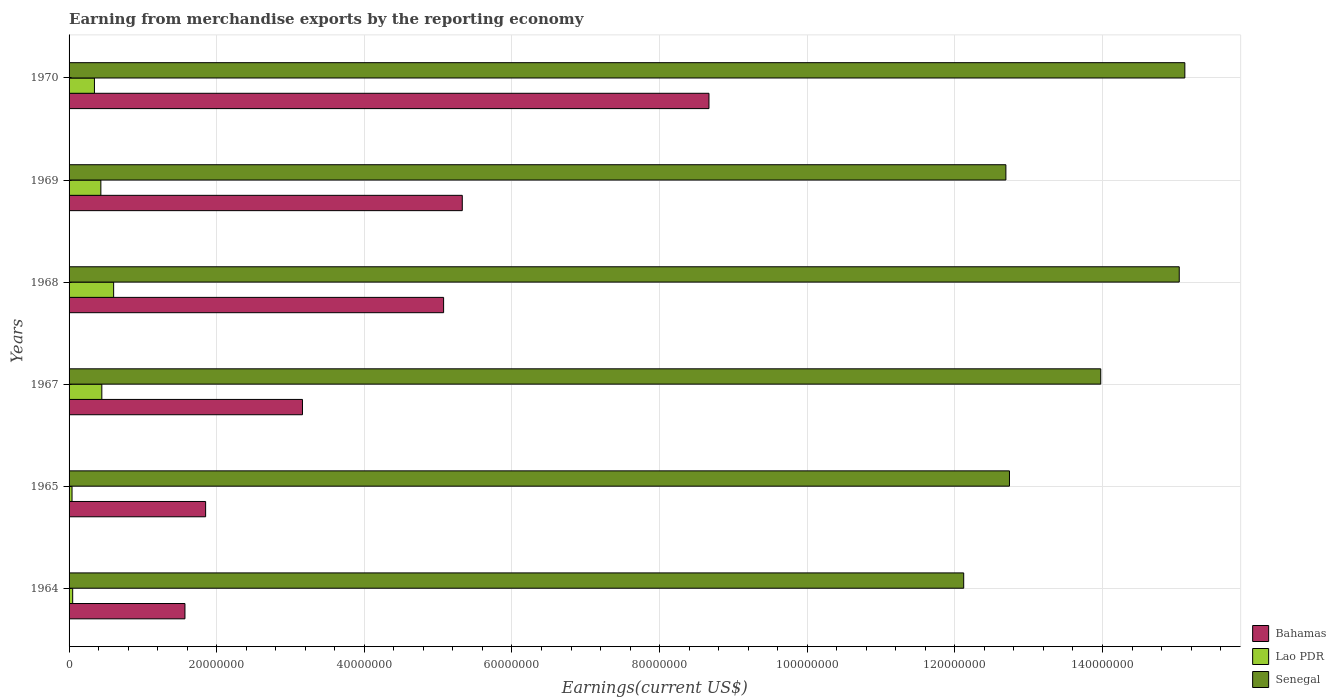How many groups of bars are there?
Your answer should be compact. 6. Are the number of bars per tick equal to the number of legend labels?
Your response must be concise. Yes. Are the number of bars on each tick of the Y-axis equal?
Provide a short and direct response. Yes. How many bars are there on the 4th tick from the bottom?
Your answer should be compact. 3. What is the label of the 2nd group of bars from the top?
Make the answer very short. 1969. What is the amount earned from merchandise exports in Senegal in 1969?
Provide a short and direct response. 1.27e+08. Across all years, what is the maximum amount earned from merchandise exports in Bahamas?
Your answer should be compact. 8.67e+07. Across all years, what is the minimum amount earned from merchandise exports in Bahamas?
Offer a terse response. 1.57e+07. In which year was the amount earned from merchandise exports in Bahamas minimum?
Ensure brevity in your answer.  1964. What is the total amount earned from merchandise exports in Bahamas in the graph?
Offer a terse response. 2.57e+08. What is the difference between the amount earned from merchandise exports in Senegal in 1964 and that in 1970?
Your answer should be compact. -3.00e+07. What is the difference between the amount earned from merchandise exports in Senegal in 1969 and the amount earned from merchandise exports in Lao PDR in 1968?
Your answer should be very brief. 1.21e+08. What is the average amount earned from merchandise exports in Senegal per year?
Ensure brevity in your answer.  1.36e+08. In the year 1970, what is the difference between the amount earned from merchandise exports in Bahamas and amount earned from merchandise exports in Senegal?
Your answer should be compact. -6.45e+07. What is the ratio of the amount earned from merchandise exports in Senegal in 1964 to that in 1968?
Keep it short and to the point. 0.81. Is the amount earned from merchandise exports in Senegal in 1965 less than that in 1970?
Provide a short and direct response. Yes. What is the difference between the highest and the second highest amount earned from merchandise exports in Senegal?
Keep it short and to the point. 7.58e+05. What is the difference between the highest and the lowest amount earned from merchandise exports in Lao PDR?
Provide a short and direct response. 5.64e+06. In how many years, is the amount earned from merchandise exports in Senegal greater than the average amount earned from merchandise exports in Senegal taken over all years?
Give a very brief answer. 3. Is the sum of the amount earned from merchandise exports in Lao PDR in 1964 and 1967 greater than the maximum amount earned from merchandise exports in Bahamas across all years?
Your answer should be very brief. No. What does the 3rd bar from the top in 1967 represents?
Your answer should be compact. Bahamas. What does the 2nd bar from the bottom in 1969 represents?
Offer a very short reply. Lao PDR. Is it the case that in every year, the sum of the amount earned from merchandise exports in Senegal and amount earned from merchandise exports in Lao PDR is greater than the amount earned from merchandise exports in Bahamas?
Your response must be concise. Yes. Are all the bars in the graph horizontal?
Offer a terse response. Yes. Where does the legend appear in the graph?
Provide a short and direct response. Bottom right. How are the legend labels stacked?
Provide a succinct answer. Vertical. What is the title of the graph?
Your answer should be compact. Earning from merchandise exports by the reporting economy. Does "Solomon Islands" appear as one of the legend labels in the graph?
Offer a very short reply. No. What is the label or title of the X-axis?
Provide a short and direct response. Earnings(current US$). What is the label or title of the Y-axis?
Offer a very short reply. Years. What is the Earnings(current US$) in Bahamas in 1964?
Your answer should be compact. 1.57e+07. What is the Earnings(current US$) in Lao PDR in 1964?
Make the answer very short. 4.90e+05. What is the Earnings(current US$) in Senegal in 1964?
Make the answer very short. 1.21e+08. What is the Earnings(current US$) of Bahamas in 1965?
Your answer should be compact. 1.85e+07. What is the Earnings(current US$) of Lao PDR in 1965?
Provide a short and direct response. 4.00e+05. What is the Earnings(current US$) of Senegal in 1965?
Your response must be concise. 1.27e+08. What is the Earnings(current US$) of Bahamas in 1967?
Provide a succinct answer. 3.16e+07. What is the Earnings(current US$) in Lao PDR in 1967?
Provide a short and direct response. 4.44e+06. What is the Earnings(current US$) in Senegal in 1967?
Keep it short and to the point. 1.40e+08. What is the Earnings(current US$) of Bahamas in 1968?
Offer a terse response. 5.07e+07. What is the Earnings(current US$) of Lao PDR in 1968?
Your response must be concise. 6.04e+06. What is the Earnings(current US$) of Senegal in 1968?
Your answer should be very brief. 1.50e+08. What is the Earnings(current US$) in Bahamas in 1969?
Your answer should be compact. 5.33e+07. What is the Earnings(current US$) in Lao PDR in 1969?
Provide a short and direct response. 4.31e+06. What is the Earnings(current US$) of Senegal in 1969?
Give a very brief answer. 1.27e+08. What is the Earnings(current US$) of Bahamas in 1970?
Make the answer very short. 8.67e+07. What is the Earnings(current US$) in Lao PDR in 1970?
Make the answer very short. 3.44e+06. What is the Earnings(current US$) of Senegal in 1970?
Offer a very short reply. 1.51e+08. Across all years, what is the maximum Earnings(current US$) in Bahamas?
Give a very brief answer. 8.67e+07. Across all years, what is the maximum Earnings(current US$) of Lao PDR?
Provide a short and direct response. 6.04e+06. Across all years, what is the maximum Earnings(current US$) of Senegal?
Ensure brevity in your answer.  1.51e+08. Across all years, what is the minimum Earnings(current US$) in Bahamas?
Ensure brevity in your answer.  1.57e+07. Across all years, what is the minimum Earnings(current US$) in Lao PDR?
Offer a terse response. 4.00e+05. Across all years, what is the minimum Earnings(current US$) of Senegal?
Offer a terse response. 1.21e+08. What is the total Earnings(current US$) of Bahamas in the graph?
Make the answer very short. 2.57e+08. What is the total Earnings(current US$) in Lao PDR in the graph?
Keep it short and to the point. 1.91e+07. What is the total Earnings(current US$) of Senegal in the graph?
Give a very brief answer. 8.17e+08. What is the difference between the Earnings(current US$) in Bahamas in 1964 and that in 1965?
Make the answer very short. -2.80e+06. What is the difference between the Earnings(current US$) in Senegal in 1964 and that in 1965?
Give a very brief answer. -6.20e+06. What is the difference between the Earnings(current US$) in Bahamas in 1964 and that in 1967?
Offer a terse response. -1.59e+07. What is the difference between the Earnings(current US$) of Lao PDR in 1964 and that in 1967?
Your answer should be compact. -3.95e+06. What is the difference between the Earnings(current US$) of Senegal in 1964 and that in 1967?
Ensure brevity in your answer.  -1.86e+07. What is the difference between the Earnings(current US$) of Bahamas in 1964 and that in 1968?
Offer a very short reply. -3.50e+07. What is the difference between the Earnings(current US$) of Lao PDR in 1964 and that in 1968?
Offer a terse response. -5.55e+06. What is the difference between the Earnings(current US$) in Senegal in 1964 and that in 1968?
Your answer should be compact. -2.92e+07. What is the difference between the Earnings(current US$) in Bahamas in 1964 and that in 1969?
Offer a very short reply. -3.76e+07. What is the difference between the Earnings(current US$) in Lao PDR in 1964 and that in 1969?
Provide a succinct answer. -3.82e+06. What is the difference between the Earnings(current US$) in Senegal in 1964 and that in 1969?
Give a very brief answer. -5.71e+06. What is the difference between the Earnings(current US$) of Bahamas in 1964 and that in 1970?
Make the answer very short. -7.10e+07. What is the difference between the Earnings(current US$) of Lao PDR in 1964 and that in 1970?
Make the answer very short. -2.95e+06. What is the difference between the Earnings(current US$) in Senegal in 1964 and that in 1970?
Keep it short and to the point. -3.00e+07. What is the difference between the Earnings(current US$) in Bahamas in 1965 and that in 1967?
Make the answer very short. -1.31e+07. What is the difference between the Earnings(current US$) in Lao PDR in 1965 and that in 1967?
Offer a terse response. -4.04e+06. What is the difference between the Earnings(current US$) of Senegal in 1965 and that in 1967?
Make the answer very short. -1.24e+07. What is the difference between the Earnings(current US$) of Bahamas in 1965 and that in 1968?
Ensure brevity in your answer.  -3.22e+07. What is the difference between the Earnings(current US$) in Lao PDR in 1965 and that in 1968?
Your answer should be compact. -5.64e+06. What is the difference between the Earnings(current US$) in Senegal in 1965 and that in 1968?
Make the answer very short. -2.30e+07. What is the difference between the Earnings(current US$) in Bahamas in 1965 and that in 1969?
Your response must be concise. -3.48e+07. What is the difference between the Earnings(current US$) of Lao PDR in 1965 and that in 1969?
Give a very brief answer. -3.91e+06. What is the difference between the Earnings(current US$) in Senegal in 1965 and that in 1969?
Keep it short and to the point. 4.86e+05. What is the difference between the Earnings(current US$) of Bahamas in 1965 and that in 1970?
Offer a very short reply. -6.82e+07. What is the difference between the Earnings(current US$) in Lao PDR in 1965 and that in 1970?
Provide a short and direct response. -3.04e+06. What is the difference between the Earnings(current US$) in Senegal in 1965 and that in 1970?
Make the answer very short. -2.38e+07. What is the difference between the Earnings(current US$) of Bahamas in 1967 and that in 1968?
Provide a short and direct response. -1.91e+07. What is the difference between the Earnings(current US$) of Lao PDR in 1967 and that in 1968?
Offer a terse response. -1.60e+06. What is the difference between the Earnings(current US$) of Senegal in 1967 and that in 1968?
Keep it short and to the point. -1.06e+07. What is the difference between the Earnings(current US$) of Bahamas in 1967 and that in 1969?
Make the answer very short. -2.16e+07. What is the difference between the Earnings(current US$) of Lao PDR in 1967 and that in 1969?
Ensure brevity in your answer.  1.31e+05. What is the difference between the Earnings(current US$) of Senegal in 1967 and that in 1969?
Your answer should be very brief. 1.29e+07. What is the difference between the Earnings(current US$) of Bahamas in 1967 and that in 1970?
Your response must be concise. -5.51e+07. What is the difference between the Earnings(current US$) in Lao PDR in 1967 and that in 1970?
Provide a succinct answer. 1.00e+06. What is the difference between the Earnings(current US$) in Senegal in 1967 and that in 1970?
Your response must be concise. -1.14e+07. What is the difference between the Earnings(current US$) of Bahamas in 1968 and that in 1969?
Provide a short and direct response. -2.53e+06. What is the difference between the Earnings(current US$) of Lao PDR in 1968 and that in 1969?
Give a very brief answer. 1.73e+06. What is the difference between the Earnings(current US$) in Senegal in 1968 and that in 1969?
Make the answer very short. 2.35e+07. What is the difference between the Earnings(current US$) in Bahamas in 1968 and that in 1970?
Your response must be concise. -3.60e+07. What is the difference between the Earnings(current US$) in Lao PDR in 1968 and that in 1970?
Provide a succinct answer. 2.60e+06. What is the difference between the Earnings(current US$) of Senegal in 1968 and that in 1970?
Give a very brief answer. -7.58e+05. What is the difference between the Earnings(current US$) of Bahamas in 1969 and that in 1970?
Make the answer very short. -3.34e+07. What is the difference between the Earnings(current US$) of Lao PDR in 1969 and that in 1970?
Offer a very short reply. 8.71e+05. What is the difference between the Earnings(current US$) in Senegal in 1969 and that in 1970?
Your answer should be compact. -2.42e+07. What is the difference between the Earnings(current US$) of Bahamas in 1964 and the Earnings(current US$) of Lao PDR in 1965?
Give a very brief answer. 1.53e+07. What is the difference between the Earnings(current US$) in Bahamas in 1964 and the Earnings(current US$) in Senegal in 1965?
Your response must be concise. -1.12e+08. What is the difference between the Earnings(current US$) in Lao PDR in 1964 and the Earnings(current US$) in Senegal in 1965?
Your answer should be compact. -1.27e+08. What is the difference between the Earnings(current US$) of Bahamas in 1964 and the Earnings(current US$) of Lao PDR in 1967?
Offer a terse response. 1.13e+07. What is the difference between the Earnings(current US$) in Bahamas in 1964 and the Earnings(current US$) in Senegal in 1967?
Provide a short and direct response. -1.24e+08. What is the difference between the Earnings(current US$) in Lao PDR in 1964 and the Earnings(current US$) in Senegal in 1967?
Keep it short and to the point. -1.39e+08. What is the difference between the Earnings(current US$) in Bahamas in 1964 and the Earnings(current US$) in Lao PDR in 1968?
Offer a terse response. 9.66e+06. What is the difference between the Earnings(current US$) of Bahamas in 1964 and the Earnings(current US$) of Senegal in 1968?
Make the answer very short. -1.35e+08. What is the difference between the Earnings(current US$) in Lao PDR in 1964 and the Earnings(current US$) in Senegal in 1968?
Make the answer very short. -1.50e+08. What is the difference between the Earnings(current US$) of Bahamas in 1964 and the Earnings(current US$) of Lao PDR in 1969?
Provide a short and direct response. 1.14e+07. What is the difference between the Earnings(current US$) in Bahamas in 1964 and the Earnings(current US$) in Senegal in 1969?
Your response must be concise. -1.11e+08. What is the difference between the Earnings(current US$) in Lao PDR in 1964 and the Earnings(current US$) in Senegal in 1969?
Your answer should be compact. -1.26e+08. What is the difference between the Earnings(current US$) in Bahamas in 1964 and the Earnings(current US$) in Lao PDR in 1970?
Make the answer very short. 1.23e+07. What is the difference between the Earnings(current US$) in Bahamas in 1964 and the Earnings(current US$) in Senegal in 1970?
Offer a terse response. -1.35e+08. What is the difference between the Earnings(current US$) in Lao PDR in 1964 and the Earnings(current US$) in Senegal in 1970?
Provide a succinct answer. -1.51e+08. What is the difference between the Earnings(current US$) in Bahamas in 1965 and the Earnings(current US$) in Lao PDR in 1967?
Offer a terse response. 1.41e+07. What is the difference between the Earnings(current US$) of Bahamas in 1965 and the Earnings(current US$) of Senegal in 1967?
Provide a short and direct response. -1.21e+08. What is the difference between the Earnings(current US$) of Lao PDR in 1965 and the Earnings(current US$) of Senegal in 1967?
Provide a short and direct response. -1.39e+08. What is the difference between the Earnings(current US$) of Bahamas in 1965 and the Earnings(current US$) of Lao PDR in 1968?
Give a very brief answer. 1.25e+07. What is the difference between the Earnings(current US$) of Bahamas in 1965 and the Earnings(current US$) of Senegal in 1968?
Ensure brevity in your answer.  -1.32e+08. What is the difference between the Earnings(current US$) of Lao PDR in 1965 and the Earnings(current US$) of Senegal in 1968?
Keep it short and to the point. -1.50e+08. What is the difference between the Earnings(current US$) of Bahamas in 1965 and the Earnings(current US$) of Lao PDR in 1969?
Provide a short and direct response. 1.42e+07. What is the difference between the Earnings(current US$) of Bahamas in 1965 and the Earnings(current US$) of Senegal in 1969?
Give a very brief answer. -1.08e+08. What is the difference between the Earnings(current US$) in Lao PDR in 1965 and the Earnings(current US$) in Senegal in 1969?
Keep it short and to the point. -1.27e+08. What is the difference between the Earnings(current US$) of Bahamas in 1965 and the Earnings(current US$) of Lao PDR in 1970?
Keep it short and to the point. 1.51e+07. What is the difference between the Earnings(current US$) of Bahamas in 1965 and the Earnings(current US$) of Senegal in 1970?
Provide a succinct answer. -1.33e+08. What is the difference between the Earnings(current US$) in Lao PDR in 1965 and the Earnings(current US$) in Senegal in 1970?
Offer a terse response. -1.51e+08. What is the difference between the Earnings(current US$) of Bahamas in 1967 and the Earnings(current US$) of Lao PDR in 1968?
Provide a short and direct response. 2.56e+07. What is the difference between the Earnings(current US$) in Bahamas in 1967 and the Earnings(current US$) in Senegal in 1968?
Provide a succinct answer. -1.19e+08. What is the difference between the Earnings(current US$) in Lao PDR in 1967 and the Earnings(current US$) in Senegal in 1968?
Ensure brevity in your answer.  -1.46e+08. What is the difference between the Earnings(current US$) of Bahamas in 1967 and the Earnings(current US$) of Lao PDR in 1969?
Your response must be concise. 2.73e+07. What is the difference between the Earnings(current US$) in Bahamas in 1967 and the Earnings(current US$) in Senegal in 1969?
Provide a succinct answer. -9.53e+07. What is the difference between the Earnings(current US$) of Lao PDR in 1967 and the Earnings(current US$) of Senegal in 1969?
Offer a terse response. -1.22e+08. What is the difference between the Earnings(current US$) of Bahamas in 1967 and the Earnings(current US$) of Lao PDR in 1970?
Offer a terse response. 2.82e+07. What is the difference between the Earnings(current US$) in Bahamas in 1967 and the Earnings(current US$) in Senegal in 1970?
Your answer should be very brief. -1.20e+08. What is the difference between the Earnings(current US$) of Lao PDR in 1967 and the Earnings(current US$) of Senegal in 1970?
Give a very brief answer. -1.47e+08. What is the difference between the Earnings(current US$) in Bahamas in 1968 and the Earnings(current US$) in Lao PDR in 1969?
Give a very brief answer. 4.64e+07. What is the difference between the Earnings(current US$) of Bahamas in 1968 and the Earnings(current US$) of Senegal in 1969?
Your answer should be very brief. -7.62e+07. What is the difference between the Earnings(current US$) of Lao PDR in 1968 and the Earnings(current US$) of Senegal in 1969?
Give a very brief answer. -1.21e+08. What is the difference between the Earnings(current US$) in Bahamas in 1968 and the Earnings(current US$) in Lao PDR in 1970?
Your answer should be very brief. 4.73e+07. What is the difference between the Earnings(current US$) in Bahamas in 1968 and the Earnings(current US$) in Senegal in 1970?
Offer a terse response. -1.00e+08. What is the difference between the Earnings(current US$) of Lao PDR in 1968 and the Earnings(current US$) of Senegal in 1970?
Offer a very short reply. -1.45e+08. What is the difference between the Earnings(current US$) of Bahamas in 1969 and the Earnings(current US$) of Lao PDR in 1970?
Offer a terse response. 4.98e+07. What is the difference between the Earnings(current US$) in Bahamas in 1969 and the Earnings(current US$) in Senegal in 1970?
Make the answer very short. -9.79e+07. What is the difference between the Earnings(current US$) in Lao PDR in 1969 and the Earnings(current US$) in Senegal in 1970?
Make the answer very short. -1.47e+08. What is the average Earnings(current US$) of Bahamas per year?
Offer a very short reply. 4.28e+07. What is the average Earnings(current US$) in Lao PDR per year?
Offer a terse response. 3.18e+06. What is the average Earnings(current US$) of Senegal per year?
Give a very brief answer. 1.36e+08. In the year 1964, what is the difference between the Earnings(current US$) of Bahamas and Earnings(current US$) of Lao PDR?
Keep it short and to the point. 1.52e+07. In the year 1964, what is the difference between the Earnings(current US$) in Bahamas and Earnings(current US$) in Senegal?
Make the answer very short. -1.06e+08. In the year 1964, what is the difference between the Earnings(current US$) in Lao PDR and Earnings(current US$) in Senegal?
Offer a very short reply. -1.21e+08. In the year 1965, what is the difference between the Earnings(current US$) of Bahamas and Earnings(current US$) of Lao PDR?
Offer a very short reply. 1.81e+07. In the year 1965, what is the difference between the Earnings(current US$) in Bahamas and Earnings(current US$) in Senegal?
Offer a terse response. -1.09e+08. In the year 1965, what is the difference between the Earnings(current US$) of Lao PDR and Earnings(current US$) of Senegal?
Your answer should be compact. -1.27e+08. In the year 1967, what is the difference between the Earnings(current US$) in Bahamas and Earnings(current US$) in Lao PDR?
Give a very brief answer. 2.72e+07. In the year 1967, what is the difference between the Earnings(current US$) of Bahamas and Earnings(current US$) of Senegal?
Your answer should be compact. -1.08e+08. In the year 1967, what is the difference between the Earnings(current US$) in Lao PDR and Earnings(current US$) in Senegal?
Make the answer very short. -1.35e+08. In the year 1968, what is the difference between the Earnings(current US$) in Bahamas and Earnings(current US$) in Lao PDR?
Give a very brief answer. 4.47e+07. In the year 1968, what is the difference between the Earnings(current US$) in Bahamas and Earnings(current US$) in Senegal?
Ensure brevity in your answer.  -9.97e+07. In the year 1968, what is the difference between the Earnings(current US$) of Lao PDR and Earnings(current US$) of Senegal?
Your response must be concise. -1.44e+08. In the year 1969, what is the difference between the Earnings(current US$) in Bahamas and Earnings(current US$) in Lao PDR?
Keep it short and to the point. 4.90e+07. In the year 1969, what is the difference between the Earnings(current US$) in Bahamas and Earnings(current US$) in Senegal?
Provide a succinct answer. -7.36e+07. In the year 1969, what is the difference between the Earnings(current US$) in Lao PDR and Earnings(current US$) in Senegal?
Your response must be concise. -1.23e+08. In the year 1970, what is the difference between the Earnings(current US$) of Bahamas and Earnings(current US$) of Lao PDR?
Provide a short and direct response. 8.33e+07. In the year 1970, what is the difference between the Earnings(current US$) in Bahamas and Earnings(current US$) in Senegal?
Offer a terse response. -6.45e+07. In the year 1970, what is the difference between the Earnings(current US$) in Lao PDR and Earnings(current US$) in Senegal?
Your response must be concise. -1.48e+08. What is the ratio of the Earnings(current US$) in Bahamas in 1964 to that in 1965?
Your answer should be compact. 0.85. What is the ratio of the Earnings(current US$) of Lao PDR in 1964 to that in 1965?
Provide a succinct answer. 1.23. What is the ratio of the Earnings(current US$) in Senegal in 1964 to that in 1965?
Your answer should be compact. 0.95. What is the ratio of the Earnings(current US$) of Bahamas in 1964 to that in 1967?
Provide a succinct answer. 0.5. What is the ratio of the Earnings(current US$) of Lao PDR in 1964 to that in 1967?
Your response must be concise. 0.11. What is the ratio of the Earnings(current US$) in Senegal in 1964 to that in 1967?
Offer a very short reply. 0.87. What is the ratio of the Earnings(current US$) of Bahamas in 1964 to that in 1968?
Provide a succinct answer. 0.31. What is the ratio of the Earnings(current US$) of Lao PDR in 1964 to that in 1968?
Offer a very short reply. 0.08. What is the ratio of the Earnings(current US$) of Senegal in 1964 to that in 1968?
Offer a very short reply. 0.81. What is the ratio of the Earnings(current US$) of Bahamas in 1964 to that in 1969?
Provide a succinct answer. 0.29. What is the ratio of the Earnings(current US$) of Lao PDR in 1964 to that in 1969?
Your answer should be very brief. 0.11. What is the ratio of the Earnings(current US$) of Senegal in 1964 to that in 1969?
Your answer should be very brief. 0.95. What is the ratio of the Earnings(current US$) in Bahamas in 1964 to that in 1970?
Make the answer very short. 0.18. What is the ratio of the Earnings(current US$) in Lao PDR in 1964 to that in 1970?
Provide a succinct answer. 0.14. What is the ratio of the Earnings(current US$) of Senegal in 1964 to that in 1970?
Provide a short and direct response. 0.8. What is the ratio of the Earnings(current US$) in Bahamas in 1965 to that in 1967?
Keep it short and to the point. 0.59. What is the ratio of the Earnings(current US$) in Lao PDR in 1965 to that in 1967?
Keep it short and to the point. 0.09. What is the ratio of the Earnings(current US$) in Senegal in 1965 to that in 1967?
Your answer should be very brief. 0.91. What is the ratio of the Earnings(current US$) in Bahamas in 1965 to that in 1968?
Give a very brief answer. 0.36. What is the ratio of the Earnings(current US$) in Lao PDR in 1965 to that in 1968?
Your answer should be very brief. 0.07. What is the ratio of the Earnings(current US$) of Senegal in 1965 to that in 1968?
Your answer should be compact. 0.85. What is the ratio of the Earnings(current US$) of Bahamas in 1965 to that in 1969?
Offer a very short reply. 0.35. What is the ratio of the Earnings(current US$) in Lao PDR in 1965 to that in 1969?
Provide a short and direct response. 0.09. What is the ratio of the Earnings(current US$) in Bahamas in 1965 to that in 1970?
Offer a very short reply. 0.21. What is the ratio of the Earnings(current US$) of Lao PDR in 1965 to that in 1970?
Your answer should be compact. 0.12. What is the ratio of the Earnings(current US$) in Senegal in 1965 to that in 1970?
Ensure brevity in your answer.  0.84. What is the ratio of the Earnings(current US$) in Bahamas in 1967 to that in 1968?
Provide a short and direct response. 0.62. What is the ratio of the Earnings(current US$) of Lao PDR in 1967 to that in 1968?
Your answer should be very brief. 0.73. What is the ratio of the Earnings(current US$) in Senegal in 1967 to that in 1968?
Give a very brief answer. 0.93. What is the ratio of the Earnings(current US$) of Bahamas in 1967 to that in 1969?
Make the answer very short. 0.59. What is the ratio of the Earnings(current US$) of Lao PDR in 1967 to that in 1969?
Offer a terse response. 1.03. What is the ratio of the Earnings(current US$) of Senegal in 1967 to that in 1969?
Provide a short and direct response. 1.1. What is the ratio of the Earnings(current US$) in Bahamas in 1967 to that in 1970?
Provide a succinct answer. 0.36. What is the ratio of the Earnings(current US$) in Lao PDR in 1967 to that in 1970?
Ensure brevity in your answer.  1.29. What is the ratio of the Earnings(current US$) of Senegal in 1967 to that in 1970?
Your answer should be very brief. 0.92. What is the ratio of the Earnings(current US$) in Bahamas in 1968 to that in 1969?
Ensure brevity in your answer.  0.95. What is the ratio of the Earnings(current US$) of Lao PDR in 1968 to that in 1969?
Make the answer very short. 1.4. What is the ratio of the Earnings(current US$) of Senegal in 1968 to that in 1969?
Offer a very short reply. 1.19. What is the ratio of the Earnings(current US$) of Bahamas in 1968 to that in 1970?
Offer a terse response. 0.59. What is the ratio of the Earnings(current US$) of Lao PDR in 1968 to that in 1970?
Your response must be concise. 1.76. What is the ratio of the Earnings(current US$) of Senegal in 1968 to that in 1970?
Keep it short and to the point. 0.99. What is the ratio of the Earnings(current US$) of Bahamas in 1969 to that in 1970?
Ensure brevity in your answer.  0.61. What is the ratio of the Earnings(current US$) in Lao PDR in 1969 to that in 1970?
Offer a terse response. 1.25. What is the ratio of the Earnings(current US$) of Senegal in 1969 to that in 1970?
Ensure brevity in your answer.  0.84. What is the difference between the highest and the second highest Earnings(current US$) of Bahamas?
Provide a short and direct response. 3.34e+07. What is the difference between the highest and the second highest Earnings(current US$) in Lao PDR?
Ensure brevity in your answer.  1.60e+06. What is the difference between the highest and the second highest Earnings(current US$) in Senegal?
Keep it short and to the point. 7.58e+05. What is the difference between the highest and the lowest Earnings(current US$) of Bahamas?
Your response must be concise. 7.10e+07. What is the difference between the highest and the lowest Earnings(current US$) in Lao PDR?
Your answer should be very brief. 5.64e+06. What is the difference between the highest and the lowest Earnings(current US$) of Senegal?
Make the answer very short. 3.00e+07. 